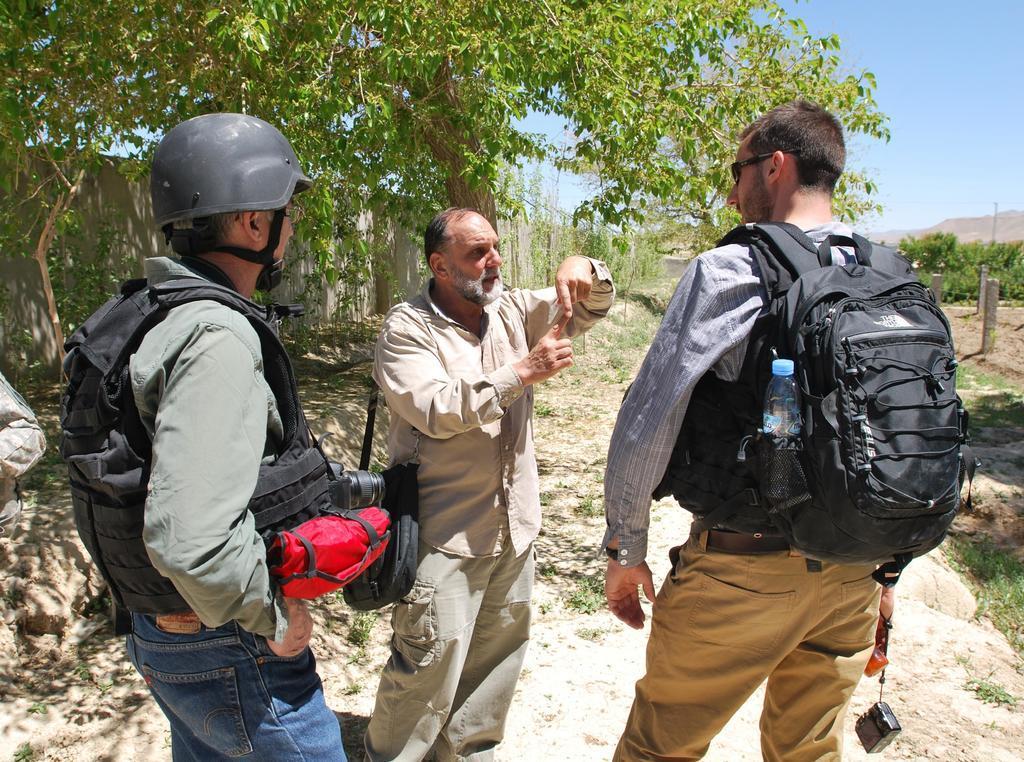Could you give a brief overview of what you see in this image? In the given image we can see there are three persons standing. The left side person is wearing helmet and the right person is caring bag and a water bottle. The middle Person is talking to the opposite person. back of him there is a tree and blue color sky. 